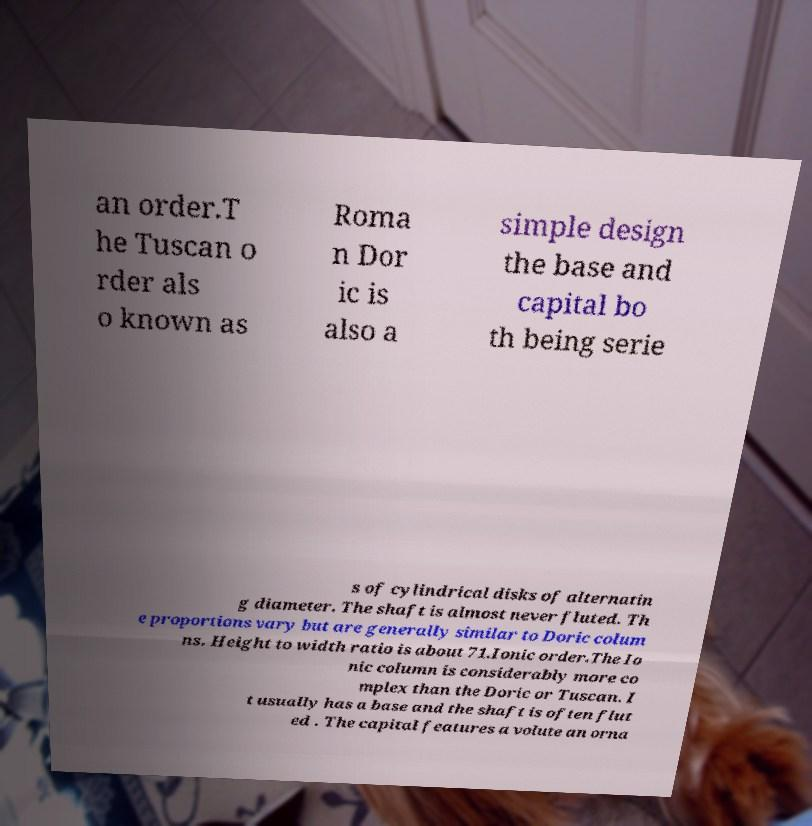Can you accurately transcribe the text from the provided image for me? an order.T he Tuscan o rder als o known as Roma n Dor ic is also a simple design the base and capital bo th being serie s of cylindrical disks of alternatin g diameter. The shaft is almost never fluted. Th e proportions vary but are generally similar to Doric colum ns. Height to width ratio is about 71.Ionic order.The Io nic column is considerably more co mplex than the Doric or Tuscan. I t usually has a base and the shaft is often flut ed . The capital features a volute an orna 